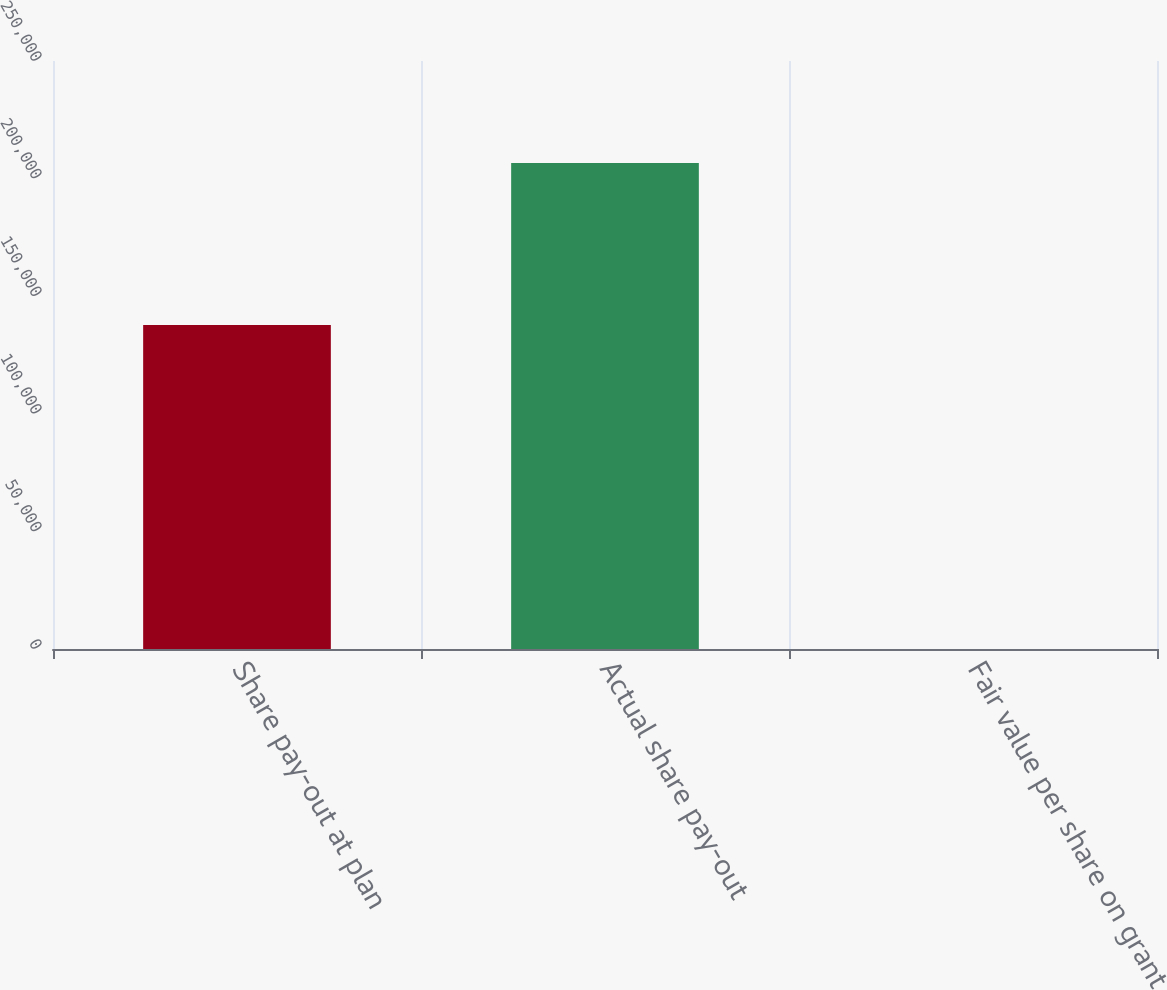<chart> <loc_0><loc_0><loc_500><loc_500><bar_chart><fcel>Share pay-out at plan<fcel>Actual share pay-out<fcel>Fair value per share on grant<nl><fcel>137778<fcel>206664<fcel>7.94<nl></chart> 